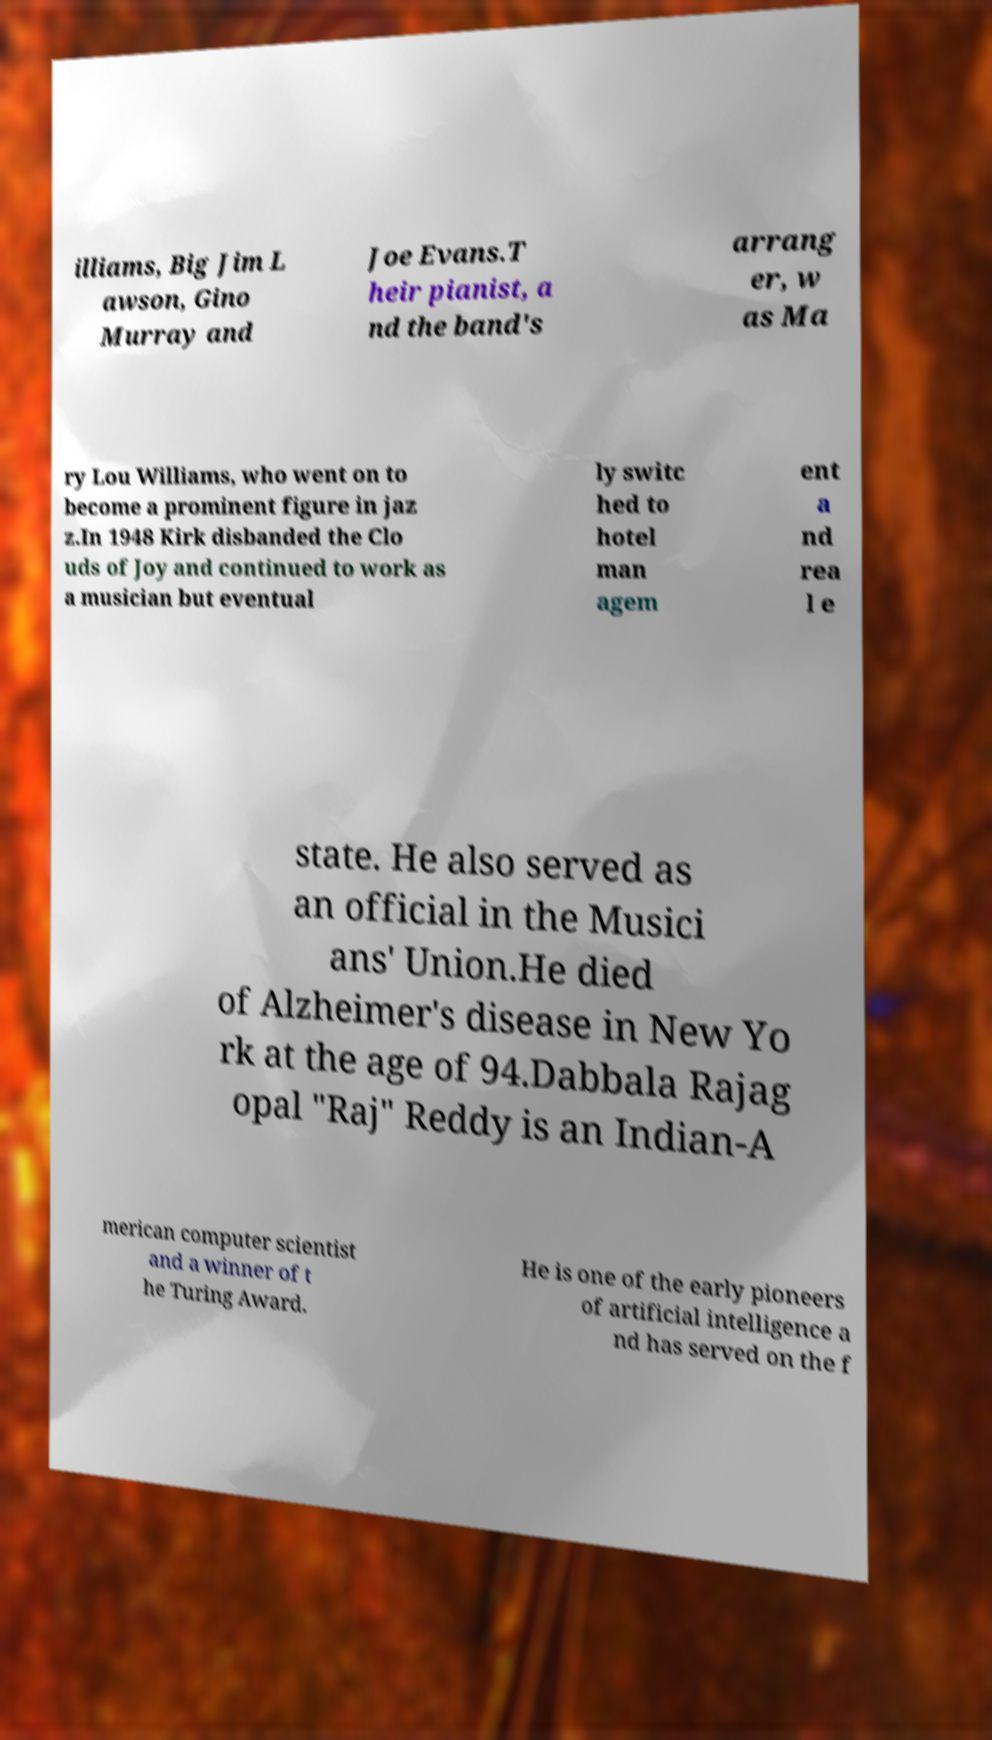Could you extract and type out the text from this image? illiams, Big Jim L awson, Gino Murray and Joe Evans.T heir pianist, a nd the band's arrang er, w as Ma ry Lou Williams, who went on to become a prominent figure in jaz z.In 1948 Kirk disbanded the Clo uds of Joy and continued to work as a musician but eventual ly switc hed to hotel man agem ent a nd rea l e state. He also served as an official in the Musici ans' Union.He died of Alzheimer's disease in New Yo rk at the age of 94.Dabbala Rajag opal "Raj" Reddy is an Indian-A merican computer scientist and a winner of t he Turing Award. He is one of the early pioneers of artificial intelligence a nd has served on the f 